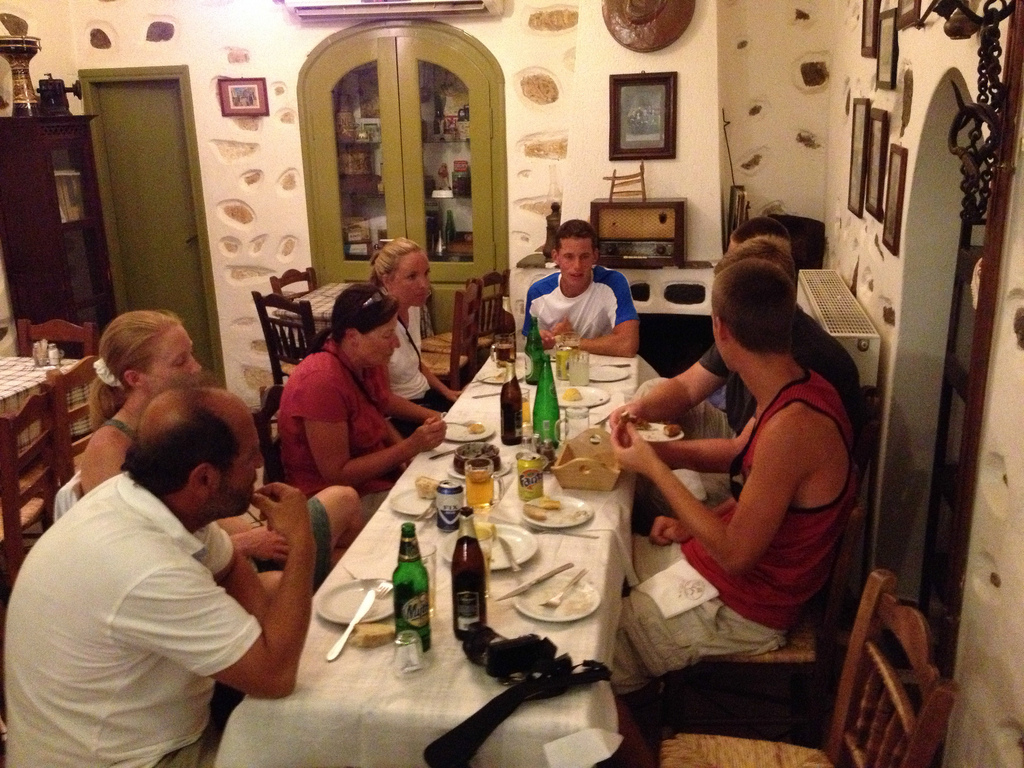Do you see any people to the left of the woman? No, there are no people immediately to the left of the woman, providing her with a bit of space amidst the bustling dinner setting. 